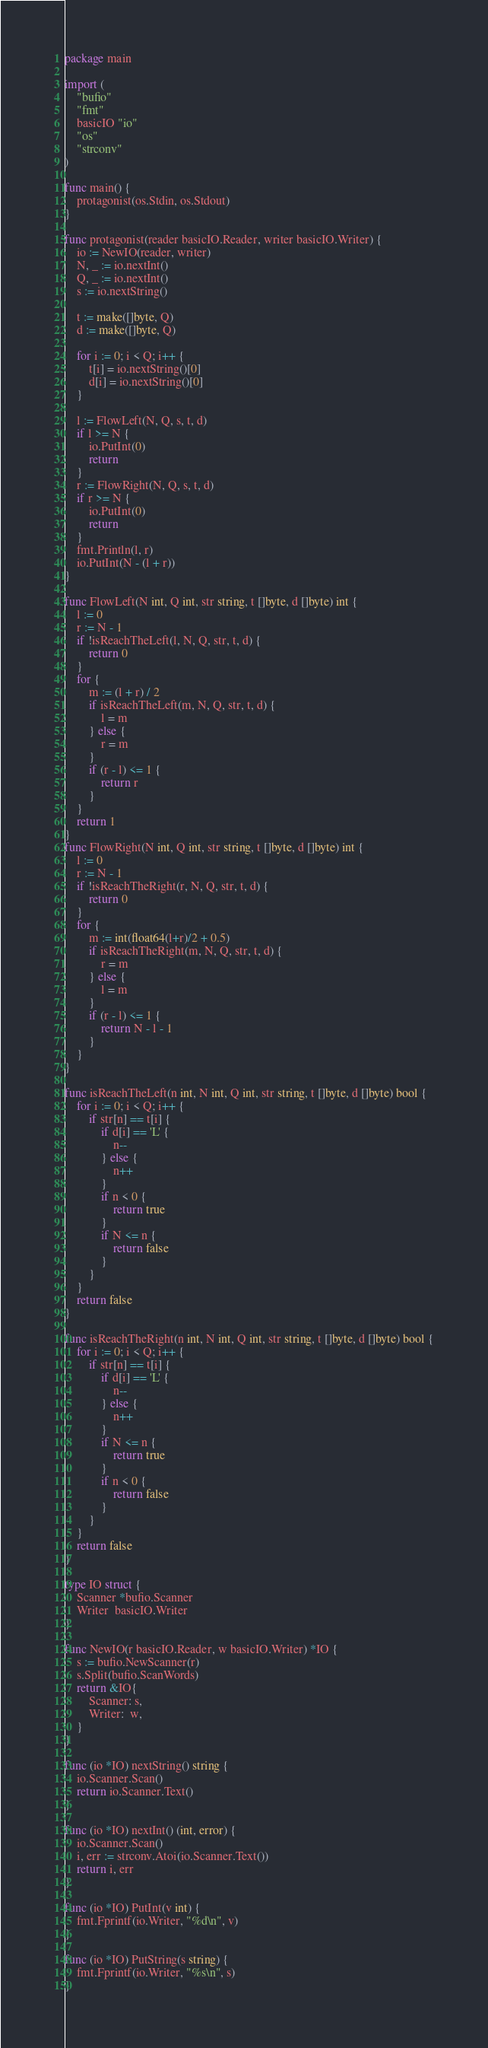Convert code to text. <code><loc_0><loc_0><loc_500><loc_500><_Go_>package main

import (
	"bufio"
	"fmt"
	basicIO "io"
	"os"
	"strconv"
)

func main() {
	protagonist(os.Stdin, os.Stdout)
}

func protagonist(reader basicIO.Reader, writer basicIO.Writer) {
	io := NewIO(reader, writer)
	N, _ := io.nextInt()
	Q, _ := io.nextInt()
	s := io.nextString()

	t := make([]byte, Q)
	d := make([]byte, Q)

	for i := 0; i < Q; i++ {
		t[i] = io.nextString()[0]
		d[i] = io.nextString()[0]
	}

	l := FlowLeft(N, Q, s, t, d)
	if l >= N {
		io.PutInt(0)
		return
	}
	r := FlowRight(N, Q, s, t, d)
	if r >= N {
		io.PutInt(0)
		return
	}
	fmt.Println(l, r)
	io.PutInt(N - (l + r))
}

func FlowLeft(N int, Q int, str string, t []byte, d []byte) int {
	l := 0
	r := N - 1
	if !isReachTheLeft(l, N, Q, str, t, d) {
		return 0
	}
	for {
		m := (l + r) / 2
		if isReachTheLeft(m, N, Q, str, t, d) {
			l = m
		} else {
			r = m
		}
		if (r - l) <= 1 {
			return r
		}
	}
	return 1
}
func FlowRight(N int, Q int, str string, t []byte, d []byte) int {
	l := 0
	r := N - 1
	if !isReachTheRight(r, N, Q, str, t, d) {
		return 0
	}
	for {
		m := int(float64(l+r)/2 + 0.5)
		if isReachTheRight(m, N, Q, str, t, d) {
			r = m
		} else {
			l = m
		}
		if (r - l) <= 1 {
			return N - l - 1
		}
	}
}

func isReachTheLeft(n int, N int, Q int, str string, t []byte, d []byte) bool {
	for i := 0; i < Q; i++ {
		if str[n] == t[i] {
			if d[i] == 'L' {
				n--
			} else {
				n++
			}
			if n < 0 {
				return true
			}
			if N <= n {
				return false
			}
		}
	}
	return false
}

func isReachTheRight(n int, N int, Q int, str string, t []byte, d []byte) bool {
	for i := 0; i < Q; i++ {
		if str[n] == t[i] {
			if d[i] == 'L' {
				n--
			} else {
				n++
			}
			if N <= n {
				return true
			}
			if n < 0 {
				return false
			}
		}
	}
	return false
}

type IO struct {
	Scanner *bufio.Scanner
	Writer  basicIO.Writer
}

func NewIO(r basicIO.Reader, w basicIO.Writer) *IO {
	s := bufio.NewScanner(r)
	s.Split(bufio.ScanWords)
	return &IO{
		Scanner: s,
		Writer:  w,
	}
}

func (io *IO) nextString() string {
	io.Scanner.Scan()
	return io.Scanner.Text()
}

func (io *IO) nextInt() (int, error) {
	io.Scanner.Scan()
	i, err := strconv.Atoi(io.Scanner.Text())
	return i, err
}

func (io *IO) PutInt(v int) {
	fmt.Fprintf(io.Writer, "%d\n", v)
}

func (io *IO) PutString(s string) {
	fmt.Fprintf(io.Writer, "%s\n", s)
}
</code> 